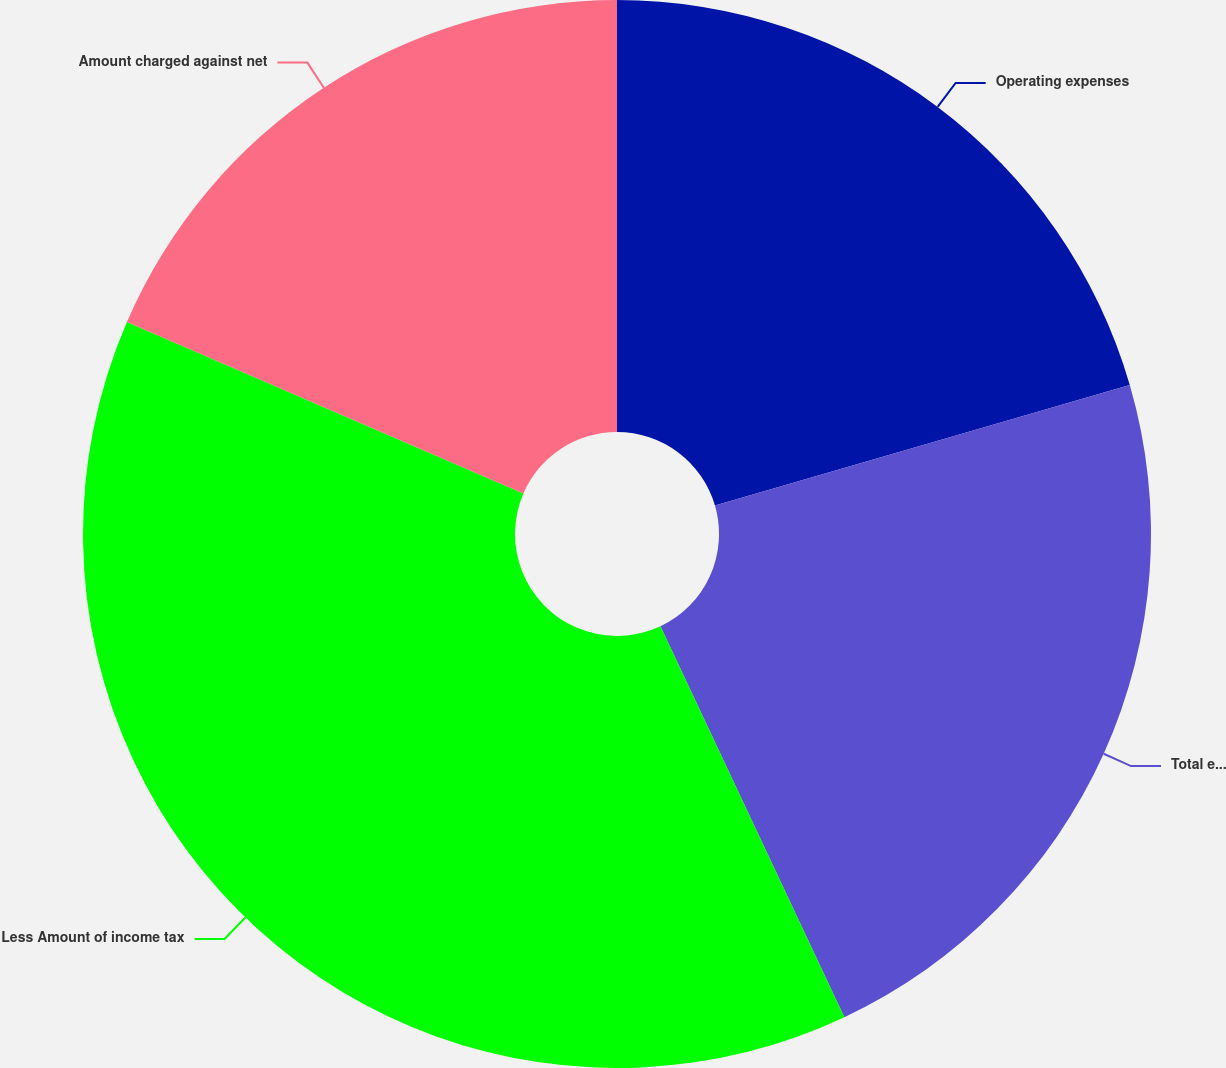Convert chart. <chart><loc_0><loc_0><loc_500><loc_500><pie_chart><fcel>Operating expenses<fcel>Total employee and<fcel>Less Amount of income tax<fcel>Amount charged against net<nl><fcel>20.5%<fcel>22.5%<fcel>38.5%<fcel>18.5%<nl></chart> 